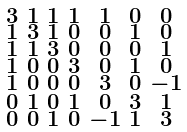<formula> <loc_0><loc_0><loc_500><loc_500>\begin{smallmatrix} 3 & 1 & 1 & 1 & 1 & 0 & 0 \\ 1 & 3 & 1 & 0 & 0 & 1 & 0 \\ 1 & 1 & 3 & 0 & 0 & 0 & 1 \\ 1 & 0 & 0 & 3 & 0 & 1 & 0 \\ 1 & 0 & 0 & 0 & 3 & 0 & - 1 \\ 0 & 1 & 0 & 1 & 0 & 3 & 1 \\ 0 & 0 & 1 & 0 & - 1 & 1 & 3 \end{smallmatrix}</formula> 